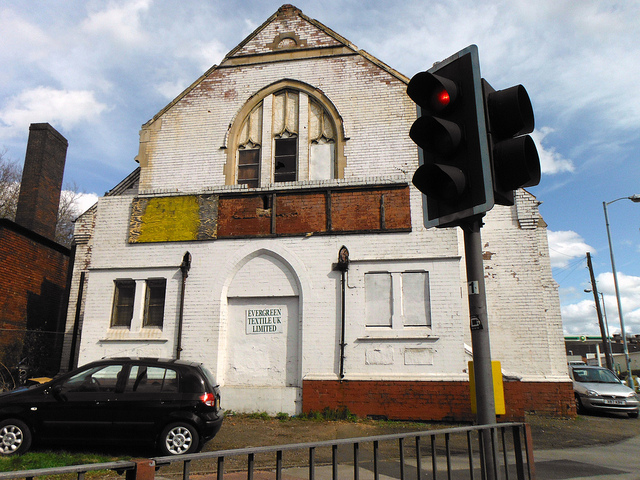Read and extract the text from this image. EVERGREEN LIMITED 1 